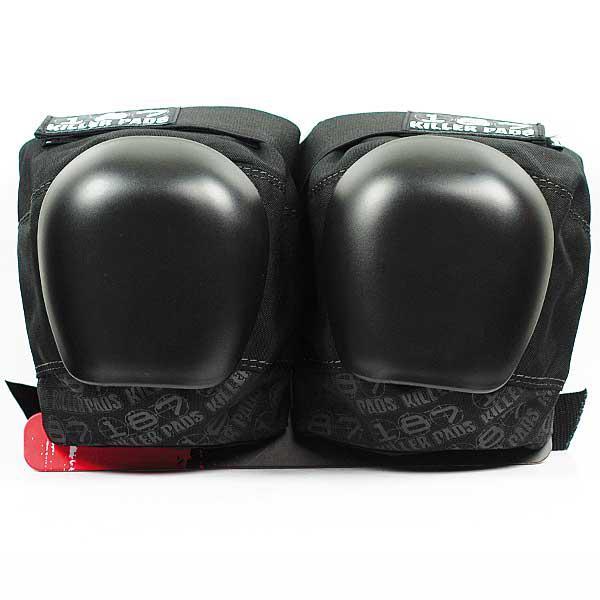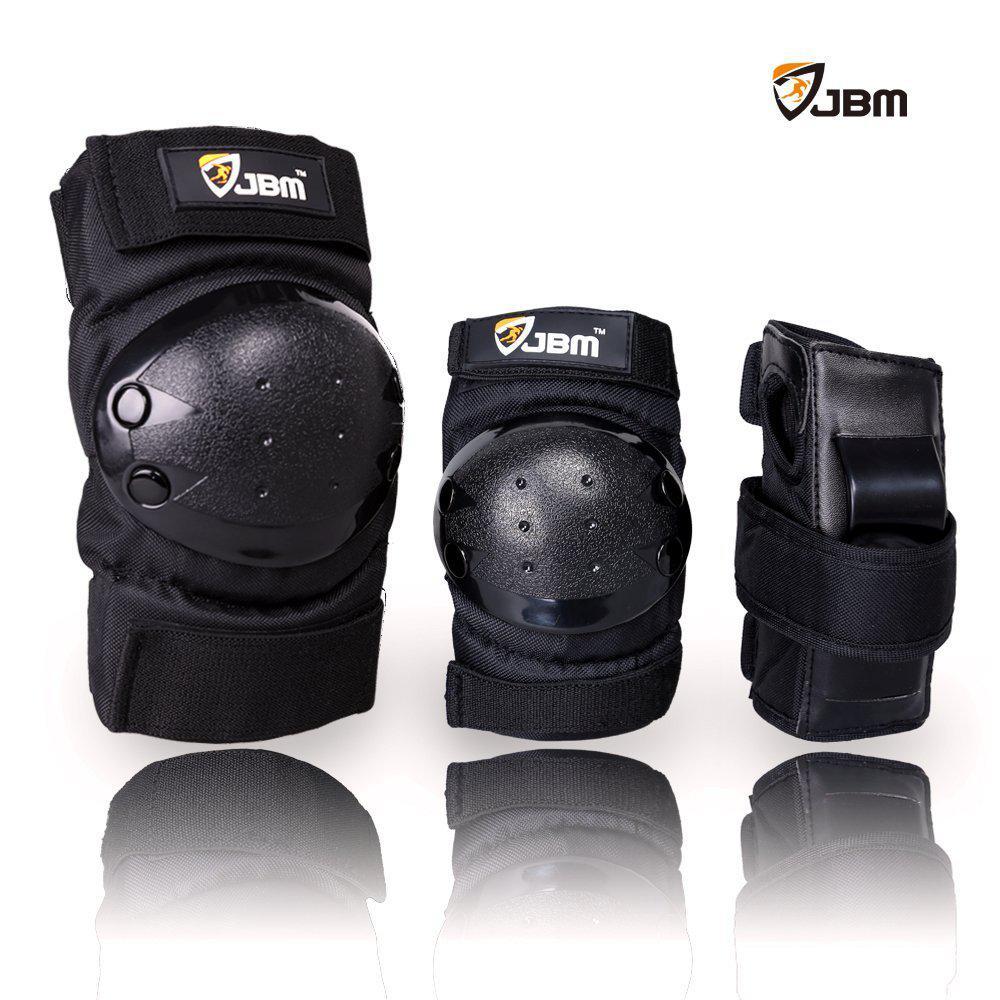The first image is the image on the left, the second image is the image on the right. Evaluate the accuracy of this statement regarding the images: "An image shows a set of three pairs of protective items, which are solid black with red on the logos.". Is it true? Answer yes or no. No. 